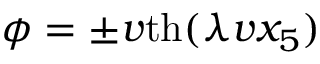Convert formula to latex. <formula><loc_0><loc_0><loc_500><loc_500>\phi = \pm v t h ( \lambda v x _ { 5 } )</formula> 